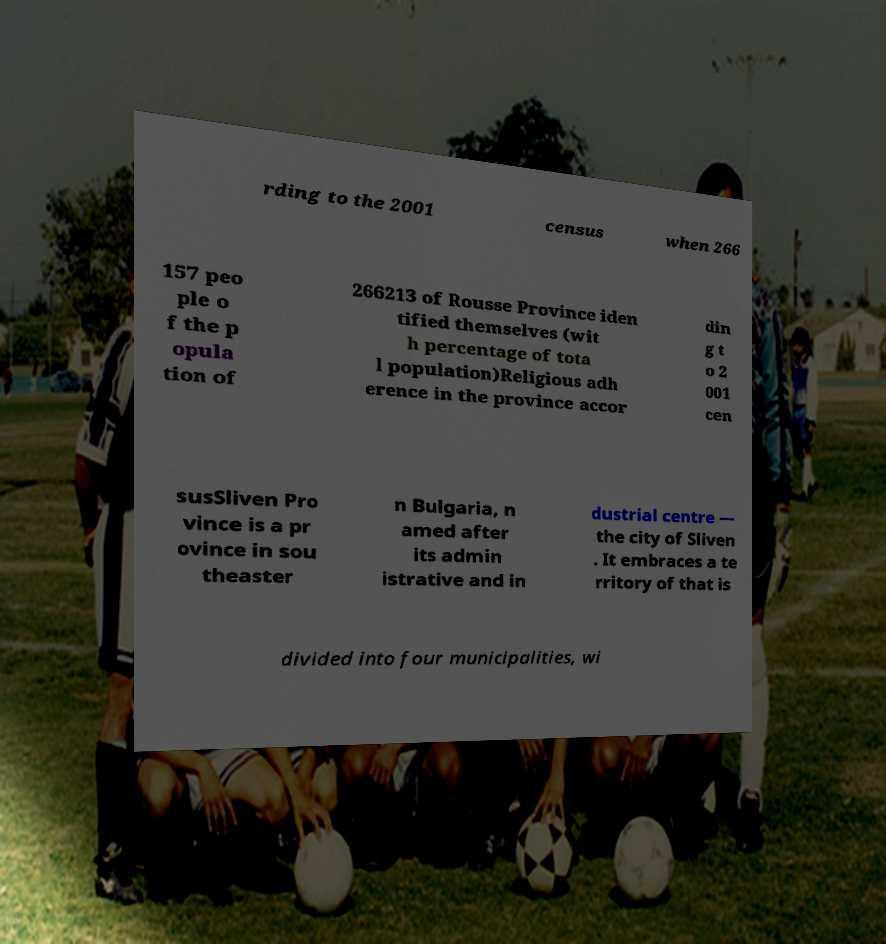Could you assist in decoding the text presented in this image and type it out clearly? rding to the 2001 census when 266 157 peo ple o f the p opula tion of 266213 of Rousse Province iden tified themselves (wit h percentage of tota l population)Religious adh erence in the province accor din g t o 2 001 cen susSliven Pro vince is a pr ovince in sou theaster n Bulgaria, n amed after its admin istrative and in dustrial centre — the city of Sliven . It embraces a te rritory of that is divided into four municipalities, wi 